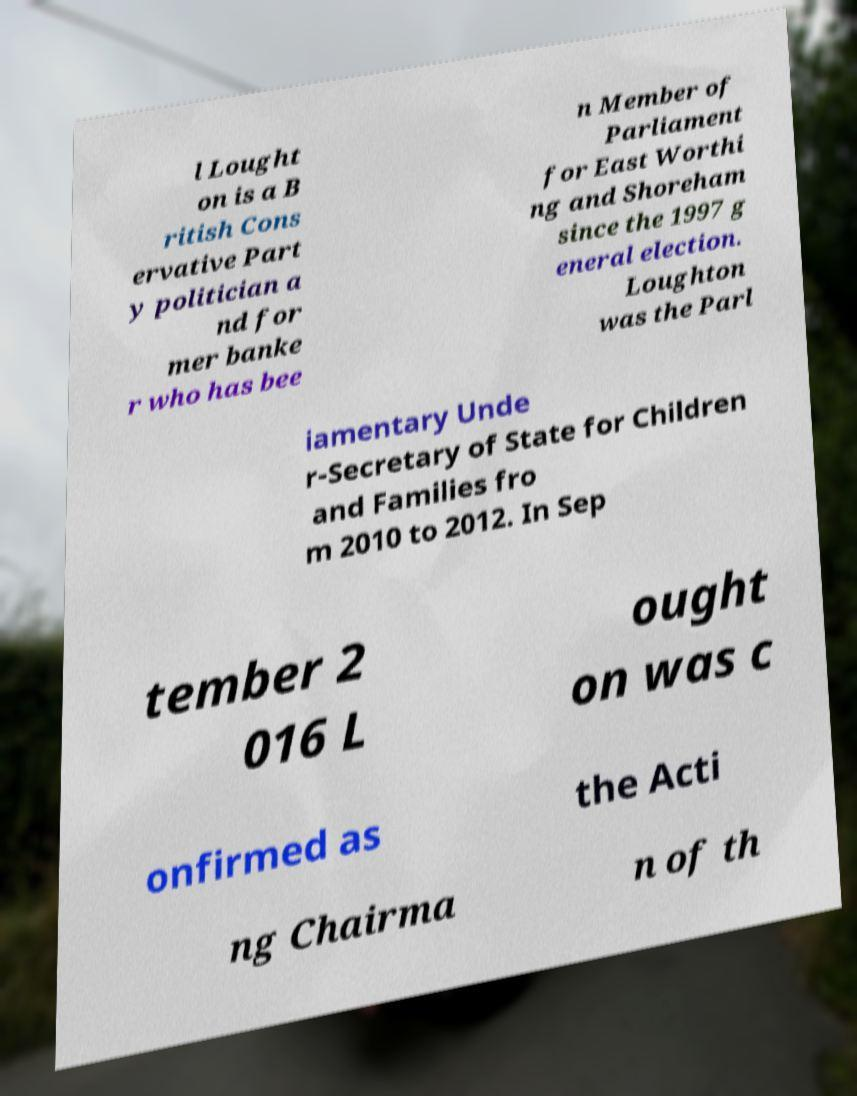Please identify and transcribe the text found in this image. l Lought on is a B ritish Cons ervative Part y politician a nd for mer banke r who has bee n Member of Parliament for East Worthi ng and Shoreham since the 1997 g eneral election. Loughton was the Parl iamentary Unde r-Secretary of State for Children and Families fro m 2010 to 2012. In Sep tember 2 016 L ought on was c onfirmed as the Acti ng Chairma n of th 